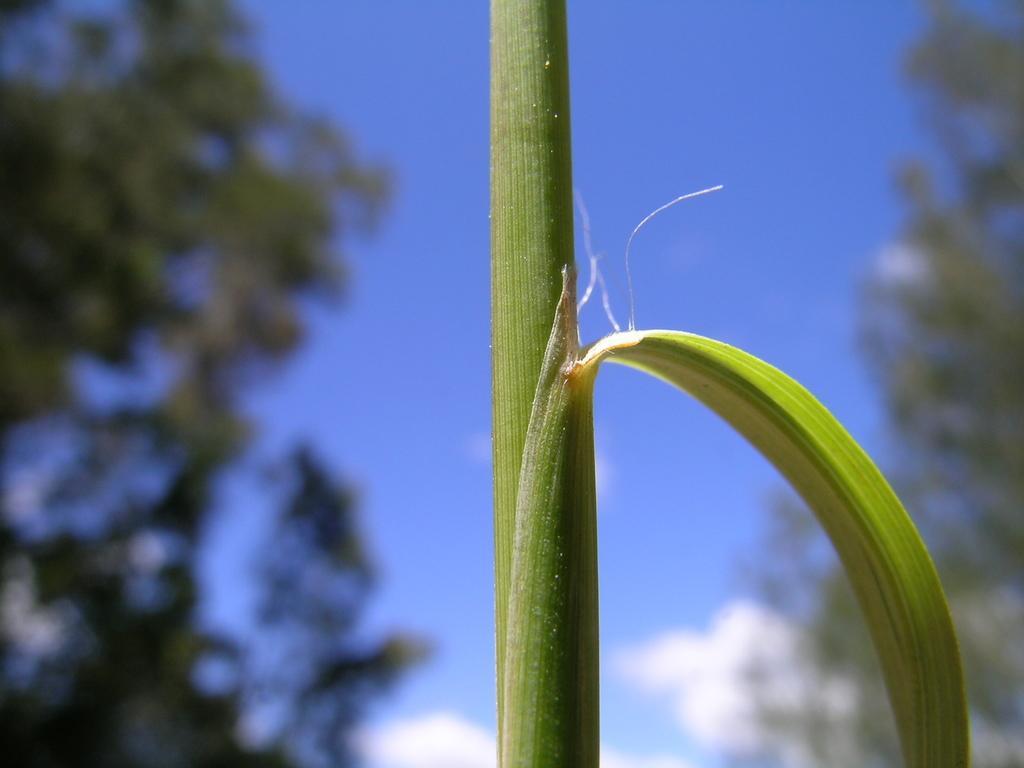Describe this image in one or two sentences. In the center of the image, we can see a stem and there is a leaf. In the background, there are trees and there is sky. 